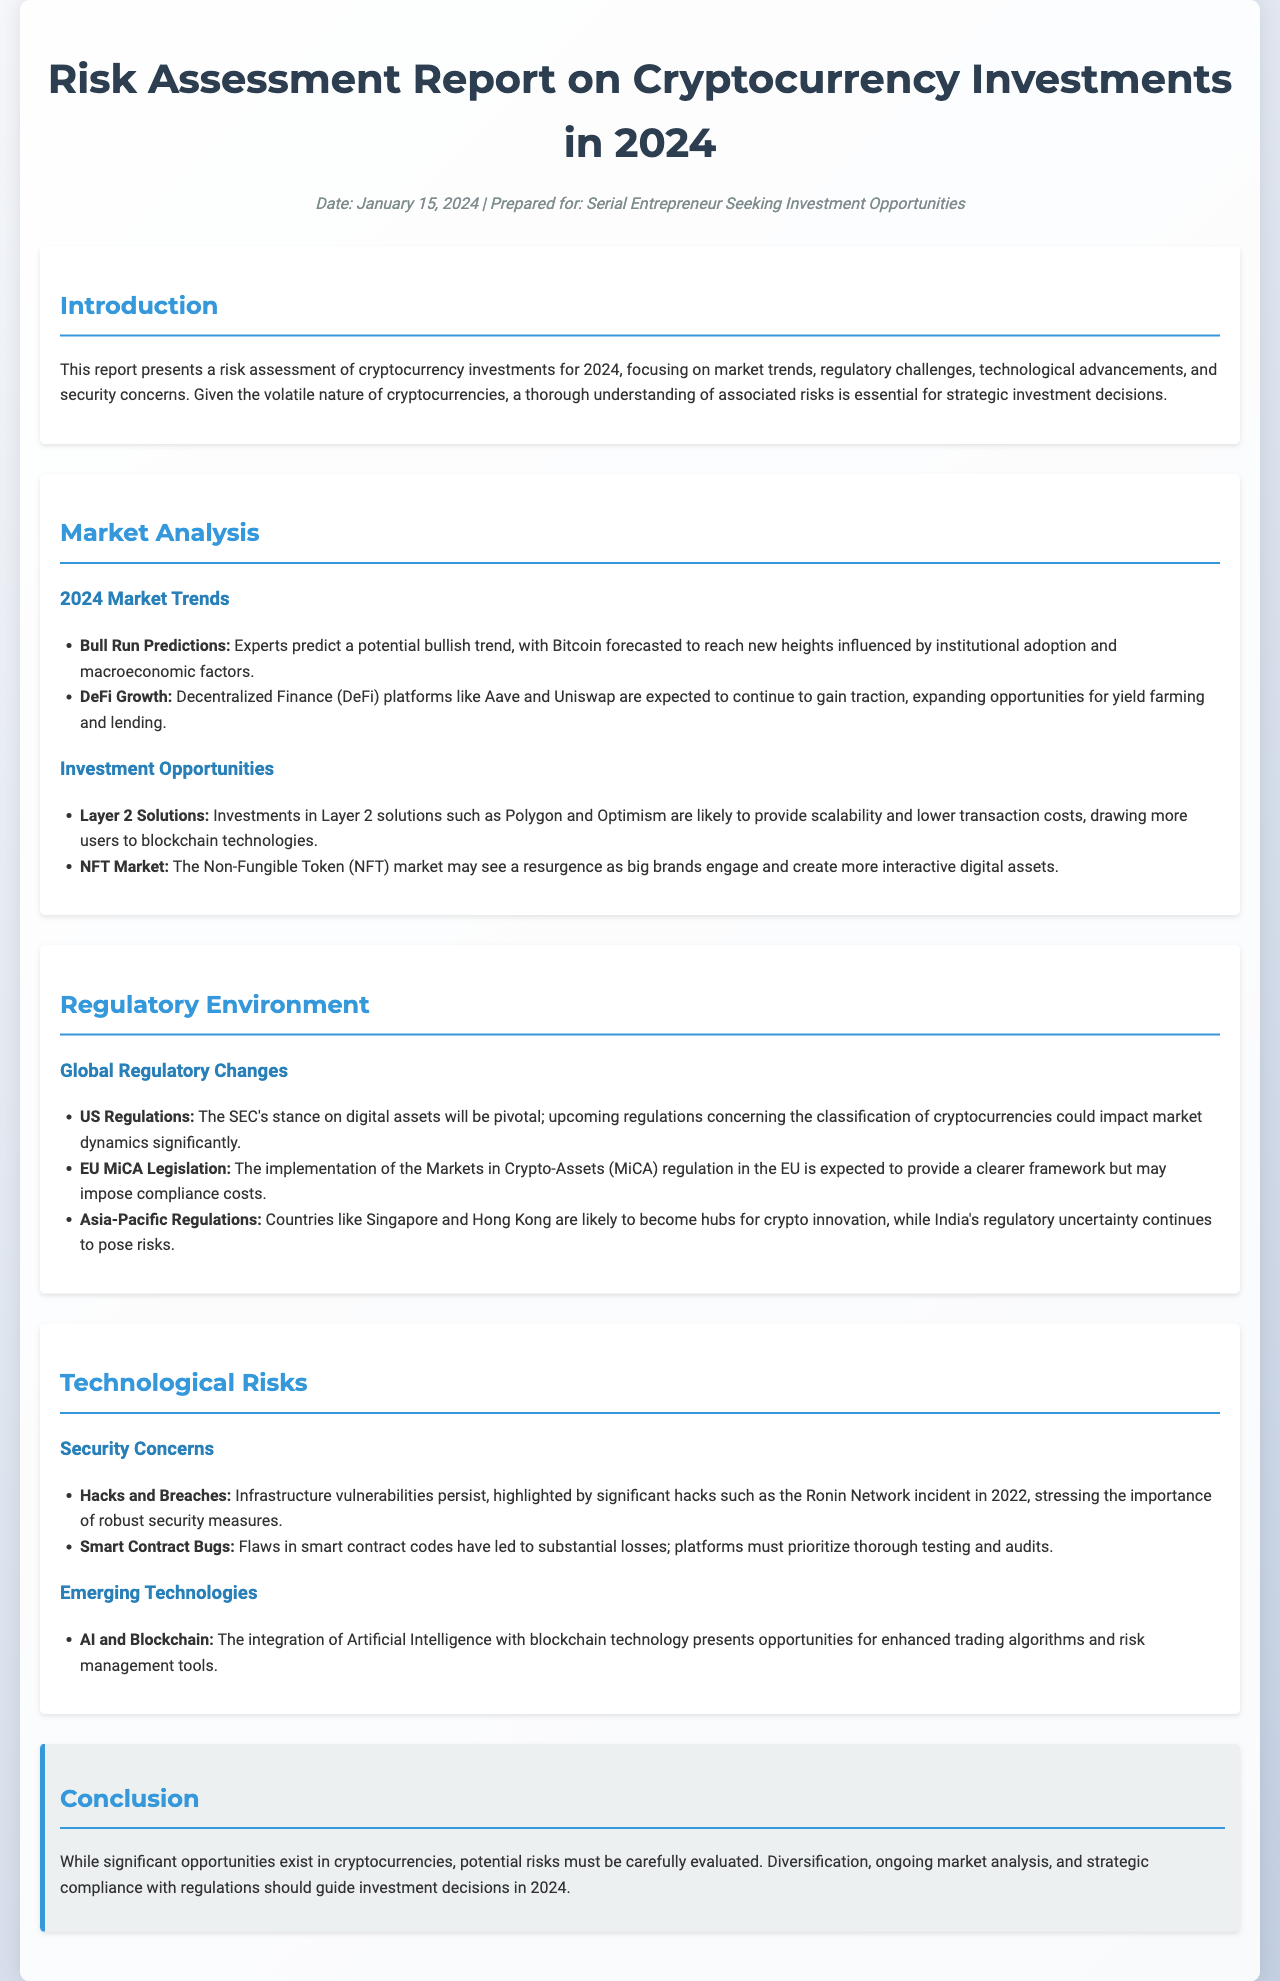What is the date of the report? The date of the report is mentioned clearly in the meta section as January 15, 2024.
Answer: January 15, 2024 What are Layer 2 Solutions mentioned in the report? Layer 2 Solutions refers to technologies like Polygon and Optimism that are discussed in the Investment Opportunities section.
Answer: Polygon and Optimism What regulatory change is expected in the EU? The report mentions the implementation of the Markets in Crypto-Assets (MiCA) regulation, which is a significant upcoming regulatory change in the EU.
Answer: MiCA regulation Which platforms are highlighted for DeFi growth? The report lists specific DeFi platforms, stating that Aave and Uniswap are expected to continue to gain traction.
Answer: Aave and Uniswap What is a major security concern mentioned? The document highlights "Hacks and Breaches" as a significant security concern in the context of cryptocurrency investments.
Answer: Hacks and Breaches How is the predicted market trend for Bitcoin characterized? The report states that experts predict a bullish trend for Bitcoin influenced by institutional adoption and macroeconomic factors, indicating its expected performance.
Answer: Bullish trend What should guide investment decisions in 2024? The conclusion emphasizes that diversification, ongoing market analysis, and strategic compliance are key factors that should guide investment decisions.
Answer: Diversification, ongoing market analysis, strategic compliance 